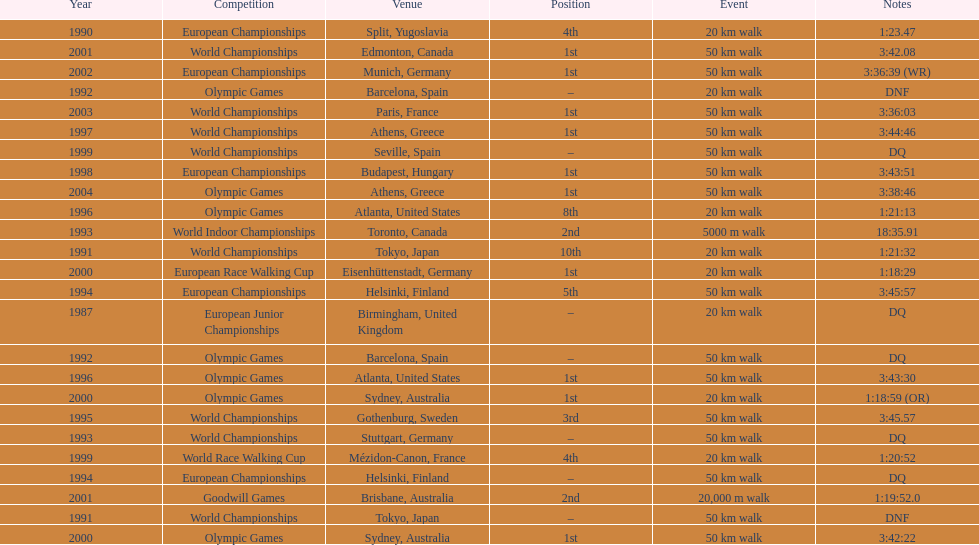Which venue is listed the most? Athens, Greece. 